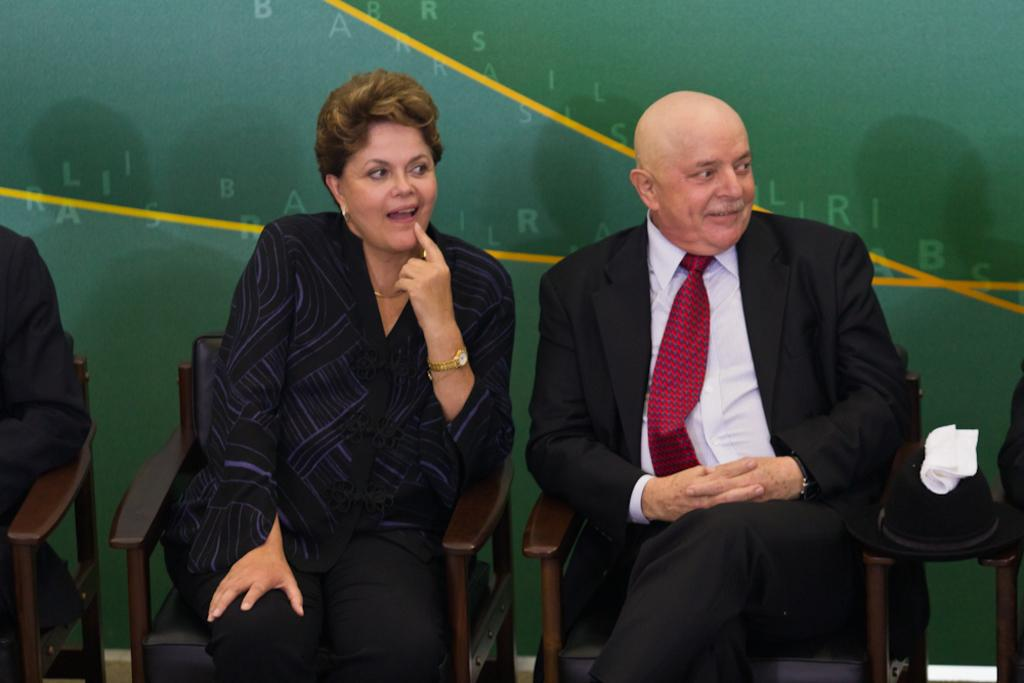What are the people in the image doing? The people in the image are sitting on chairs. What objects can be seen on the table in the image? There is a helmet and a kerchief on the table. What type of owl can be seen sitting on the stove in the image? There is no stove or owl present in the image. 